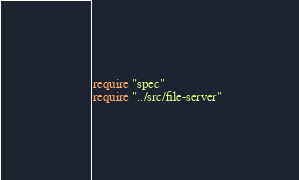<code> <loc_0><loc_0><loc_500><loc_500><_Crystal_>require "spec"
require "../src/file-server"
</code> 